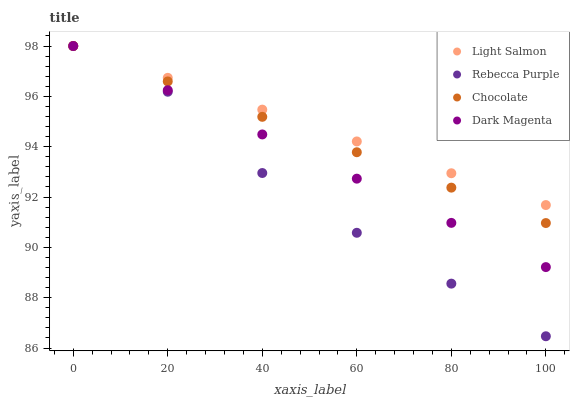Does Rebecca Purple have the minimum area under the curve?
Answer yes or no. Yes. Does Light Salmon have the maximum area under the curve?
Answer yes or no. Yes. Does Dark Magenta have the minimum area under the curve?
Answer yes or no. No. Does Dark Magenta have the maximum area under the curve?
Answer yes or no. No. Is Dark Magenta the smoothest?
Answer yes or no. Yes. Is Rebecca Purple the roughest?
Answer yes or no. Yes. Is Rebecca Purple the smoothest?
Answer yes or no. No. Is Dark Magenta the roughest?
Answer yes or no. No. Does Rebecca Purple have the lowest value?
Answer yes or no. Yes. Does Dark Magenta have the lowest value?
Answer yes or no. No. Does Chocolate have the highest value?
Answer yes or no. Yes. Does Rebecca Purple intersect Light Salmon?
Answer yes or no. Yes. Is Rebecca Purple less than Light Salmon?
Answer yes or no. No. Is Rebecca Purple greater than Light Salmon?
Answer yes or no. No. 